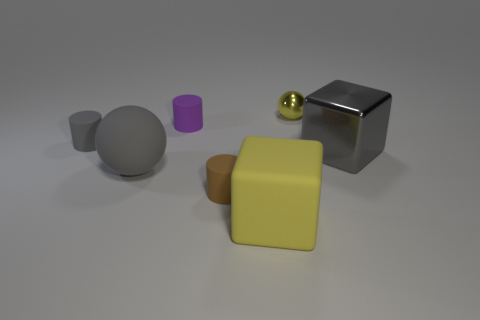Subtract all brown cylinders. How many cylinders are left? 2 Add 2 gray metal objects. How many objects exist? 9 Subtract 3 cylinders. How many cylinders are left? 0 Subtract all cubes. How many objects are left? 5 Subtract all purple cylinders. How many cylinders are left? 2 Subtract all blocks. Subtract all small yellow objects. How many objects are left? 4 Add 6 small brown rubber things. How many small brown rubber things are left? 7 Add 6 purple objects. How many purple objects exist? 7 Subtract 1 yellow spheres. How many objects are left? 6 Subtract all purple blocks. Subtract all purple cylinders. How many blocks are left? 2 